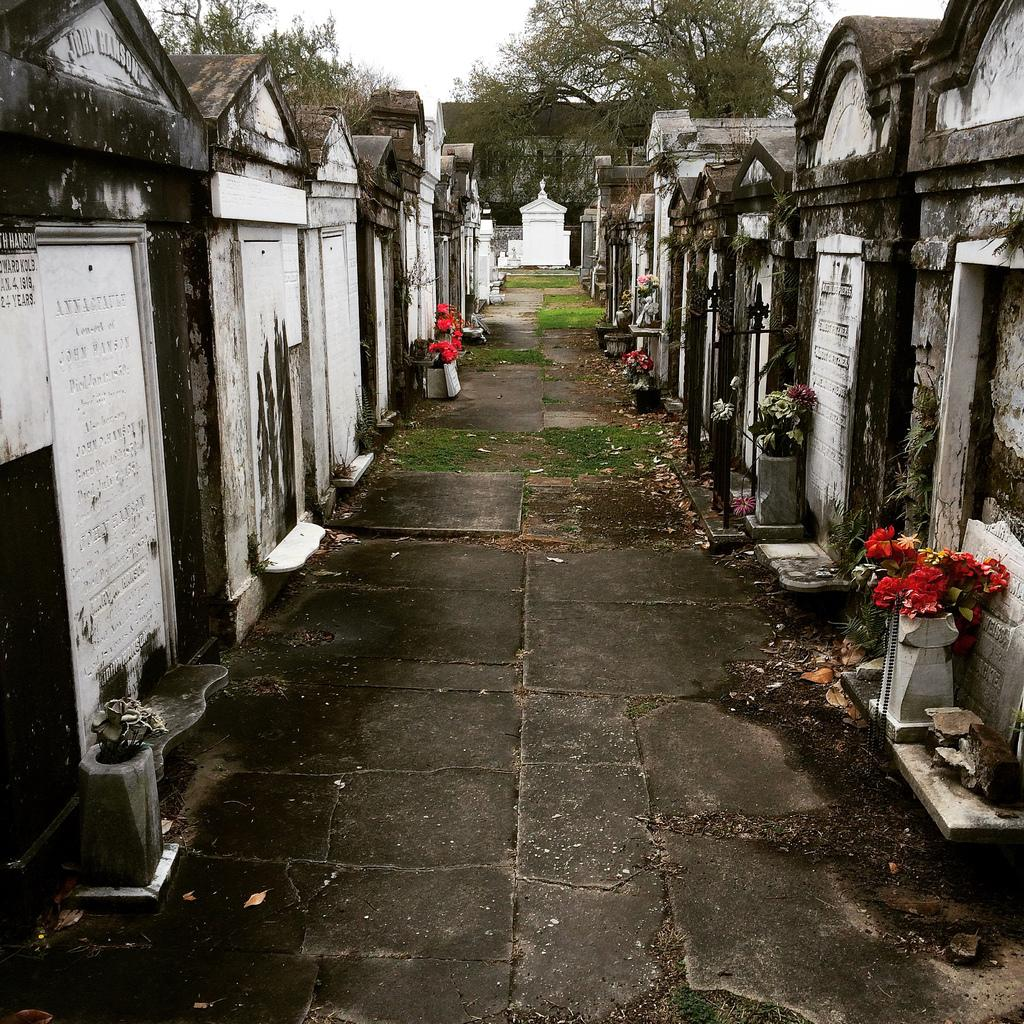What type of location is depicted in the image? The image contains a graveyard. What can be seen on the graves in the image? There is text on the graves in the image. What type of decorations are present in the image? Flower bouquets are present in the image. What can be seen in the background of the image? There are trees and the sky visible in the background of the image. What language is the person in the image speaking? There is no person speaking in the image; it is a photograph of a graveyard. How does the person in the image express their opinion about the graveyard? There is no person present in the image, so their opinion cannot be determined. 